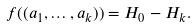<formula> <loc_0><loc_0><loc_500><loc_500>f ( ( a _ { 1 } , \dots , a _ { k } ) ) = H _ { 0 } - H _ { k } .</formula> 